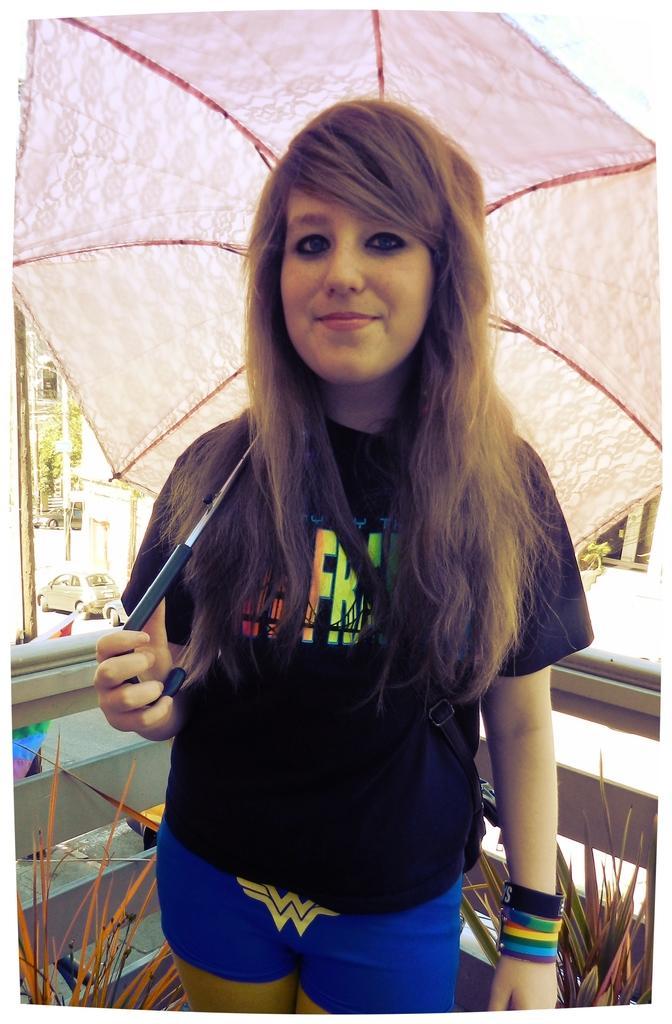Please provide a concise description of this image. In this picture we can see a woman in the black t shirt is holding an umbrella. Behind the women there are house plants, a tree, poles and vehicles on the road. Behind the houseplants, those are looking like grilles. 